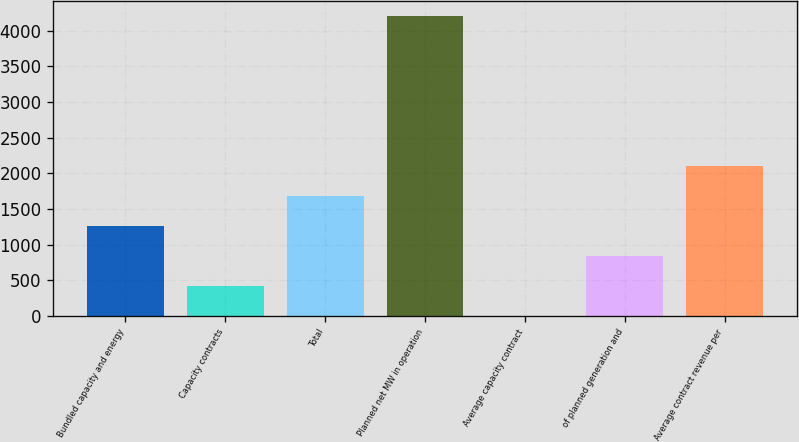Convert chart to OTSL. <chart><loc_0><loc_0><loc_500><loc_500><bar_chart><fcel>Bundled capacity and energy<fcel>Capacity contracts<fcel>Total<fcel>Planned net MW in operation<fcel>Average capacity contract<fcel>of planned generation and<fcel>Average contract revenue per<nl><fcel>1260.63<fcel>420.81<fcel>1680.54<fcel>4200<fcel>0.9<fcel>840.72<fcel>2100.45<nl></chart> 